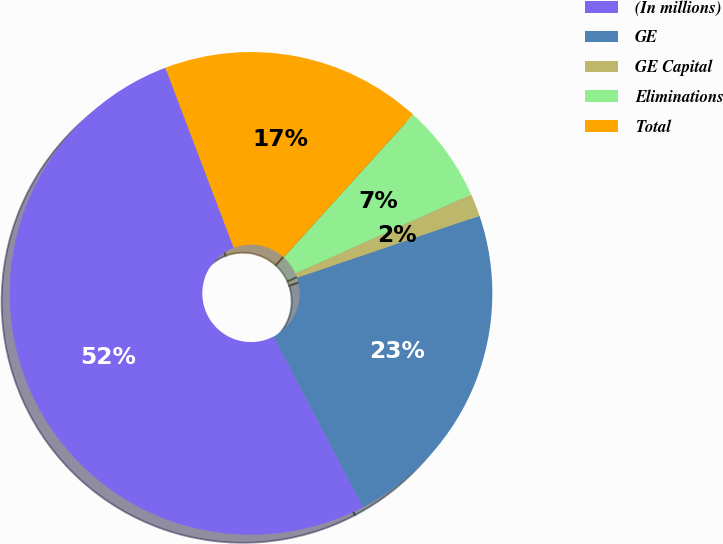Convert chart. <chart><loc_0><loc_0><loc_500><loc_500><pie_chart><fcel>(In millions)<fcel>GE<fcel>GE Capital<fcel>Eliminations<fcel>Total<nl><fcel>51.92%<fcel>22.53%<fcel>1.51%<fcel>6.56%<fcel>17.49%<nl></chart> 